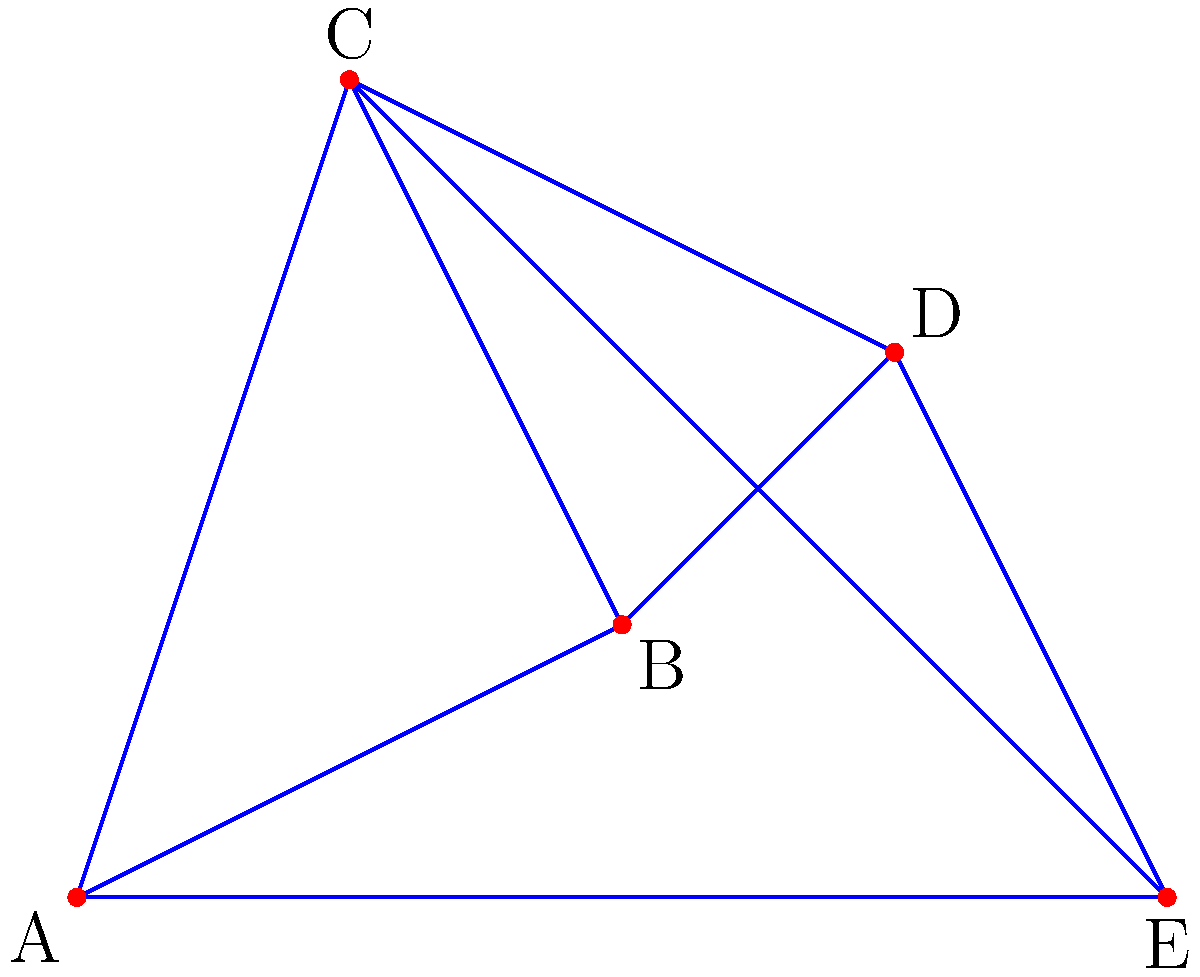A series of crimes have been committed at locations A, B, C, D, and E. The investigator claims that the topological structure of the crime scenes forms a planar graph. As a true crime enthusiast and amateur profiler who disagrees with the investigator's findings, what is the minimum number of edges that need to be removed to make this graph planar, proving the investigator wrong? To approach this problem, we need to analyze the given graph and compare it to known non-planar graphs:

1. The graph has 5 vertices (A, B, C, D, E) and 8 edges.
2. A planar graph with 5 vertices can have at most 9 edges (using the formula $E \leq 3V - 6$ for planar graphs, where E is the number of edges and V is the number of vertices).
3. However, the structure of this graph is important, not just the number of edges.
4. The graph contains a subgraph isomorphic to $K_{3,3}$ (complete bipartite graph):
   - Set 1: {A, C, E}
   - Set 2: {B, D}
   - Every vertex in Set 1 is connected to every vertex in Set 2
5. $K_{3,3}$ is a known non-planar graph.
6. To make a $K_{3,3}$ graph planar, we need to remove at least one edge.
7. Therefore, to make the given graph planar, we need to remove at least one edge.

This proves that the investigator's claim of the graph being planar is incorrect, as we need to remove at least one edge to make it planar.
Answer: 1 edge 